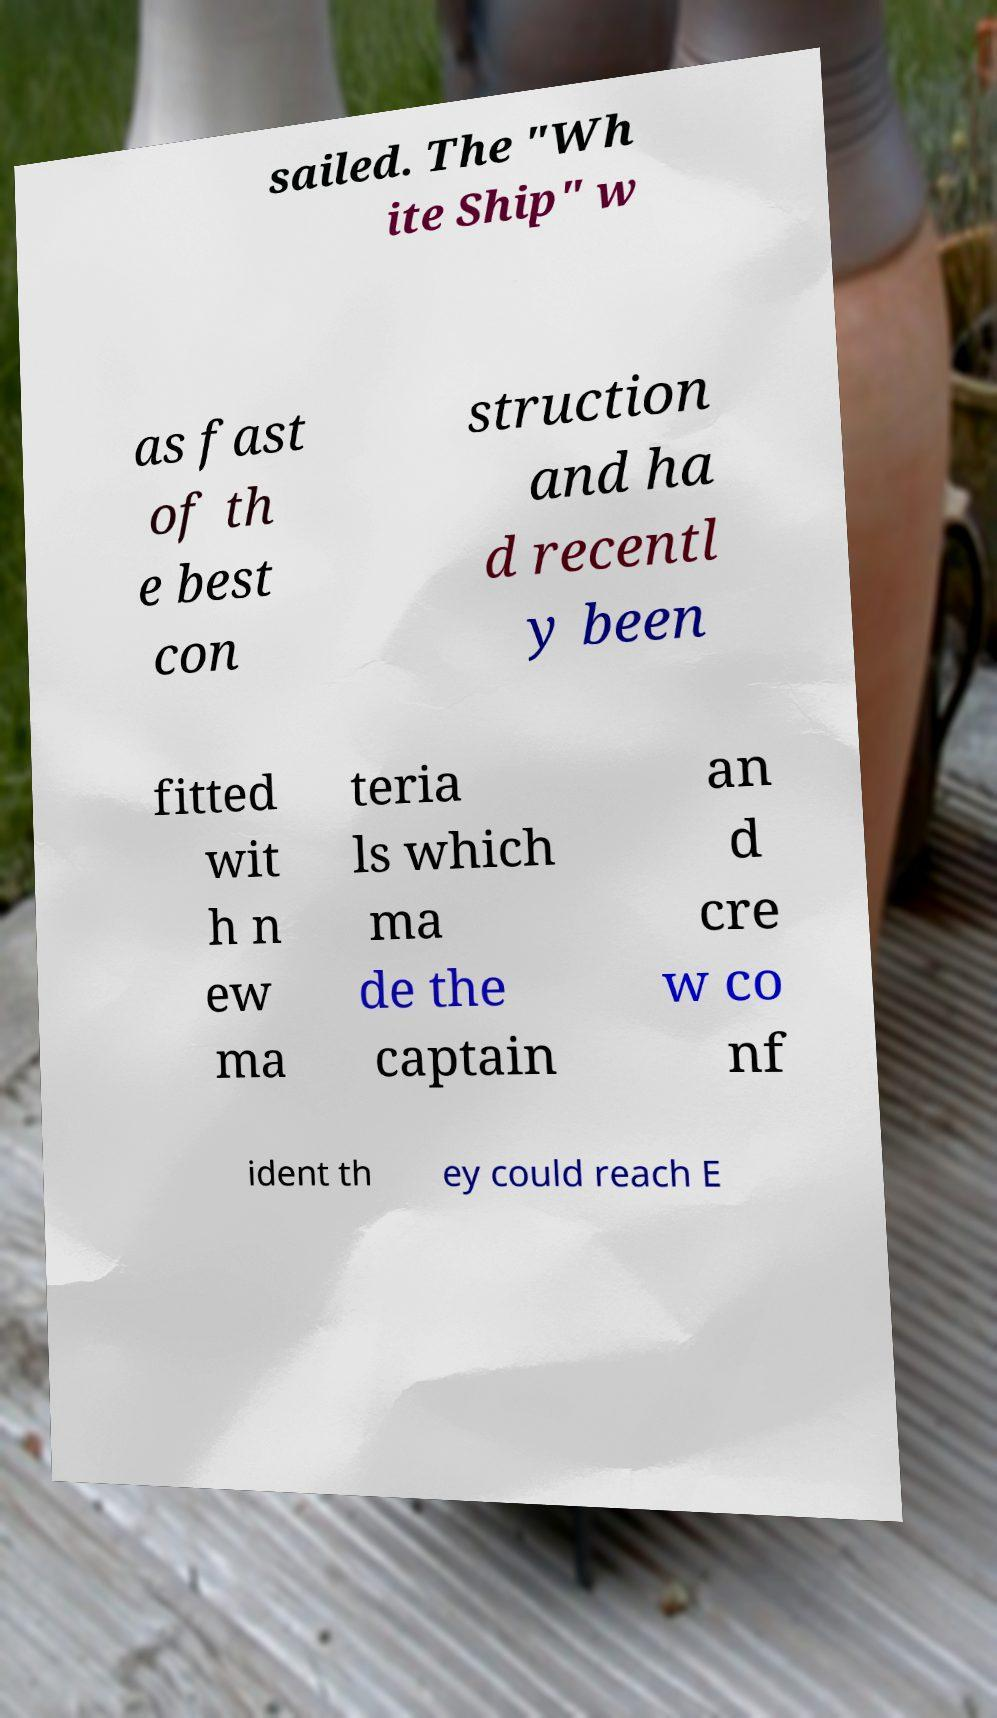What messages or text are displayed in this image? I need them in a readable, typed format. sailed. The "Wh ite Ship" w as fast of th e best con struction and ha d recentl y been fitted wit h n ew ma teria ls which ma de the captain an d cre w co nf ident th ey could reach E 